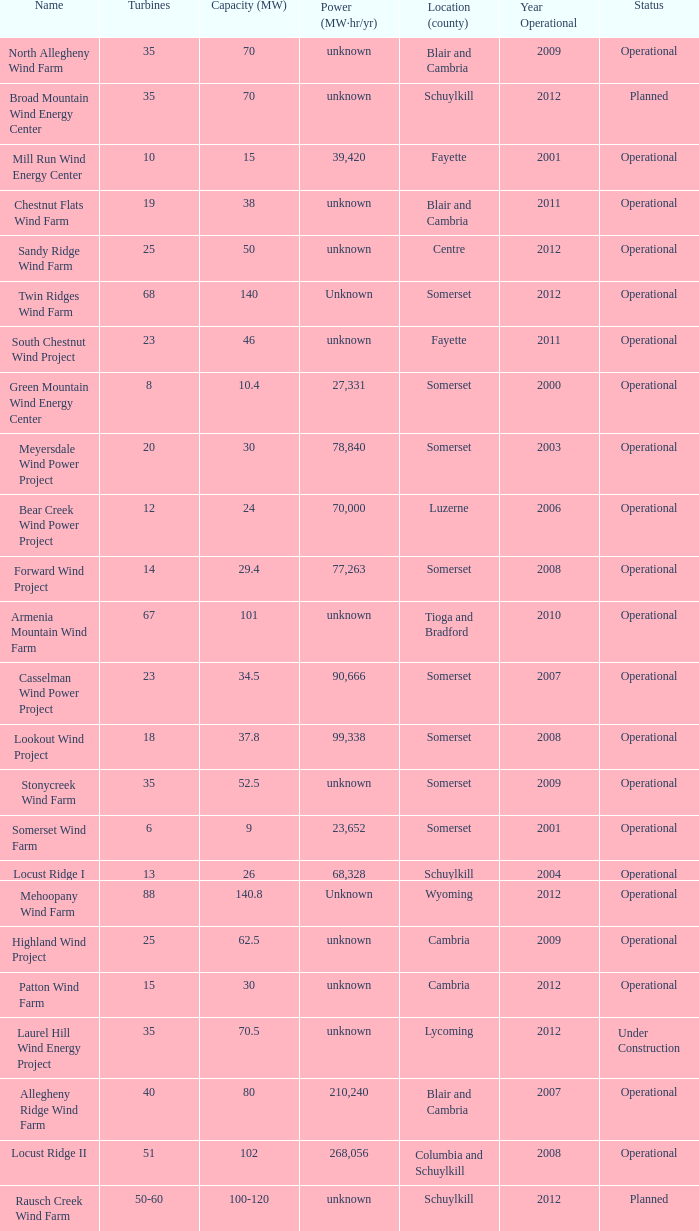What year was Fayette operational at 46? 2011.0. Can you parse all the data within this table? {'header': ['Name', 'Turbines', 'Capacity (MW)', 'Power (MW·hr/yr)', 'Location (county)', 'Year Operational', 'Status'], 'rows': [['North Allegheny Wind Farm', '35', '70', 'unknown', 'Blair and Cambria', '2009', 'Operational'], ['Broad Mountain Wind Energy Center', '35', '70', 'unknown', 'Schuylkill', '2012', 'Planned'], ['Mill Run Wind Energy Center', '10', '15', '39,420', 'Fayette', '2001', 'Operational'], ['Chestnut Flats Wind Farm', '19', '38', 'unknown', 'Blair and Cambria', '2011', 'Operational'], ['Sandy Ridge Wind Farm', '25', '50', 'unknown', 'Centre', '2012', 'Operational'], ['Twin Ridges Wind Farm', '68', '140', 'Unknown', 'Somerset', '2012', 'Operational'], ['South Chestnut Wind Project', '23', '46', 'unknown', 'Fayette', '2011', 'Operational'], ['Green Mountain Wind Energy Center', '8', '10.4', '27,331', 'Somerset', '2000', 'Operational'], ['Meyersdale Wind Power Project', '20', '30', '78,840', 'Somerset', '2003', 'Operational'], ['Bear Creek Wind Power Project', '12', '24', '70,000', 'Luzerne', '2006', 'Operational'], ['Forward Wind Project', '14', '29.4', '77,263', 'Somerset', '2008', 'Operational'], ['Armenia Mountain Wind Farm', '67', '101', 'unknown', 'Tioga and Bradford', '2010', 'Operational'], ['Casselman Wind Power Project', '23', '34.5', '90,666', 'Somerset', '2007', 'Operational'], ['Lookout Wind Project', '18', '37.8', '99,338', 'Somerset', '2008', 'Operational'], ['Stonycreek Wind Farm', '35', '52.5', 'unknown', 'Somerset', '2009', 'Operational'], ['Somerset Wind Farm', '6', '9', '23,652', 'Somerset', '2001', 'Operational'], ['Locust Ridge I', '13', '26', '68,328', 'Schuylkill', '2004', 'Operational'], ['Mehoopany Wind Farm', '88', '140.8', 'Unknown', 'Wyoming', '2012', 'Operational'], ['Highland Wind Project', '25', '62.5', 'unknown', 'Cambria', '2009', 'Operational'], ['Patton Wind Farm', '15', '30', 'unknown', 'Cambria', '2012', 'Operational'], ['Laurel Hill Wind Energy Project', '35', '70.5', 'unknown', 'Lycoming', '2012', 'Under Construction'], ['Allegheny Ridge Wind Farm', '40', '80', '210,240', 'Blair and Cambria', '2007', 'Operational'], ['Locust Ridge II', '51', '102', '268,056', 'Columbia and Schuylkill', '2008', 'Operational'], ['Rausch Creek Wind Farm', '50-60', '100-120', 'unknown', 'Schuylkill', '2012', 'Planned']]} 